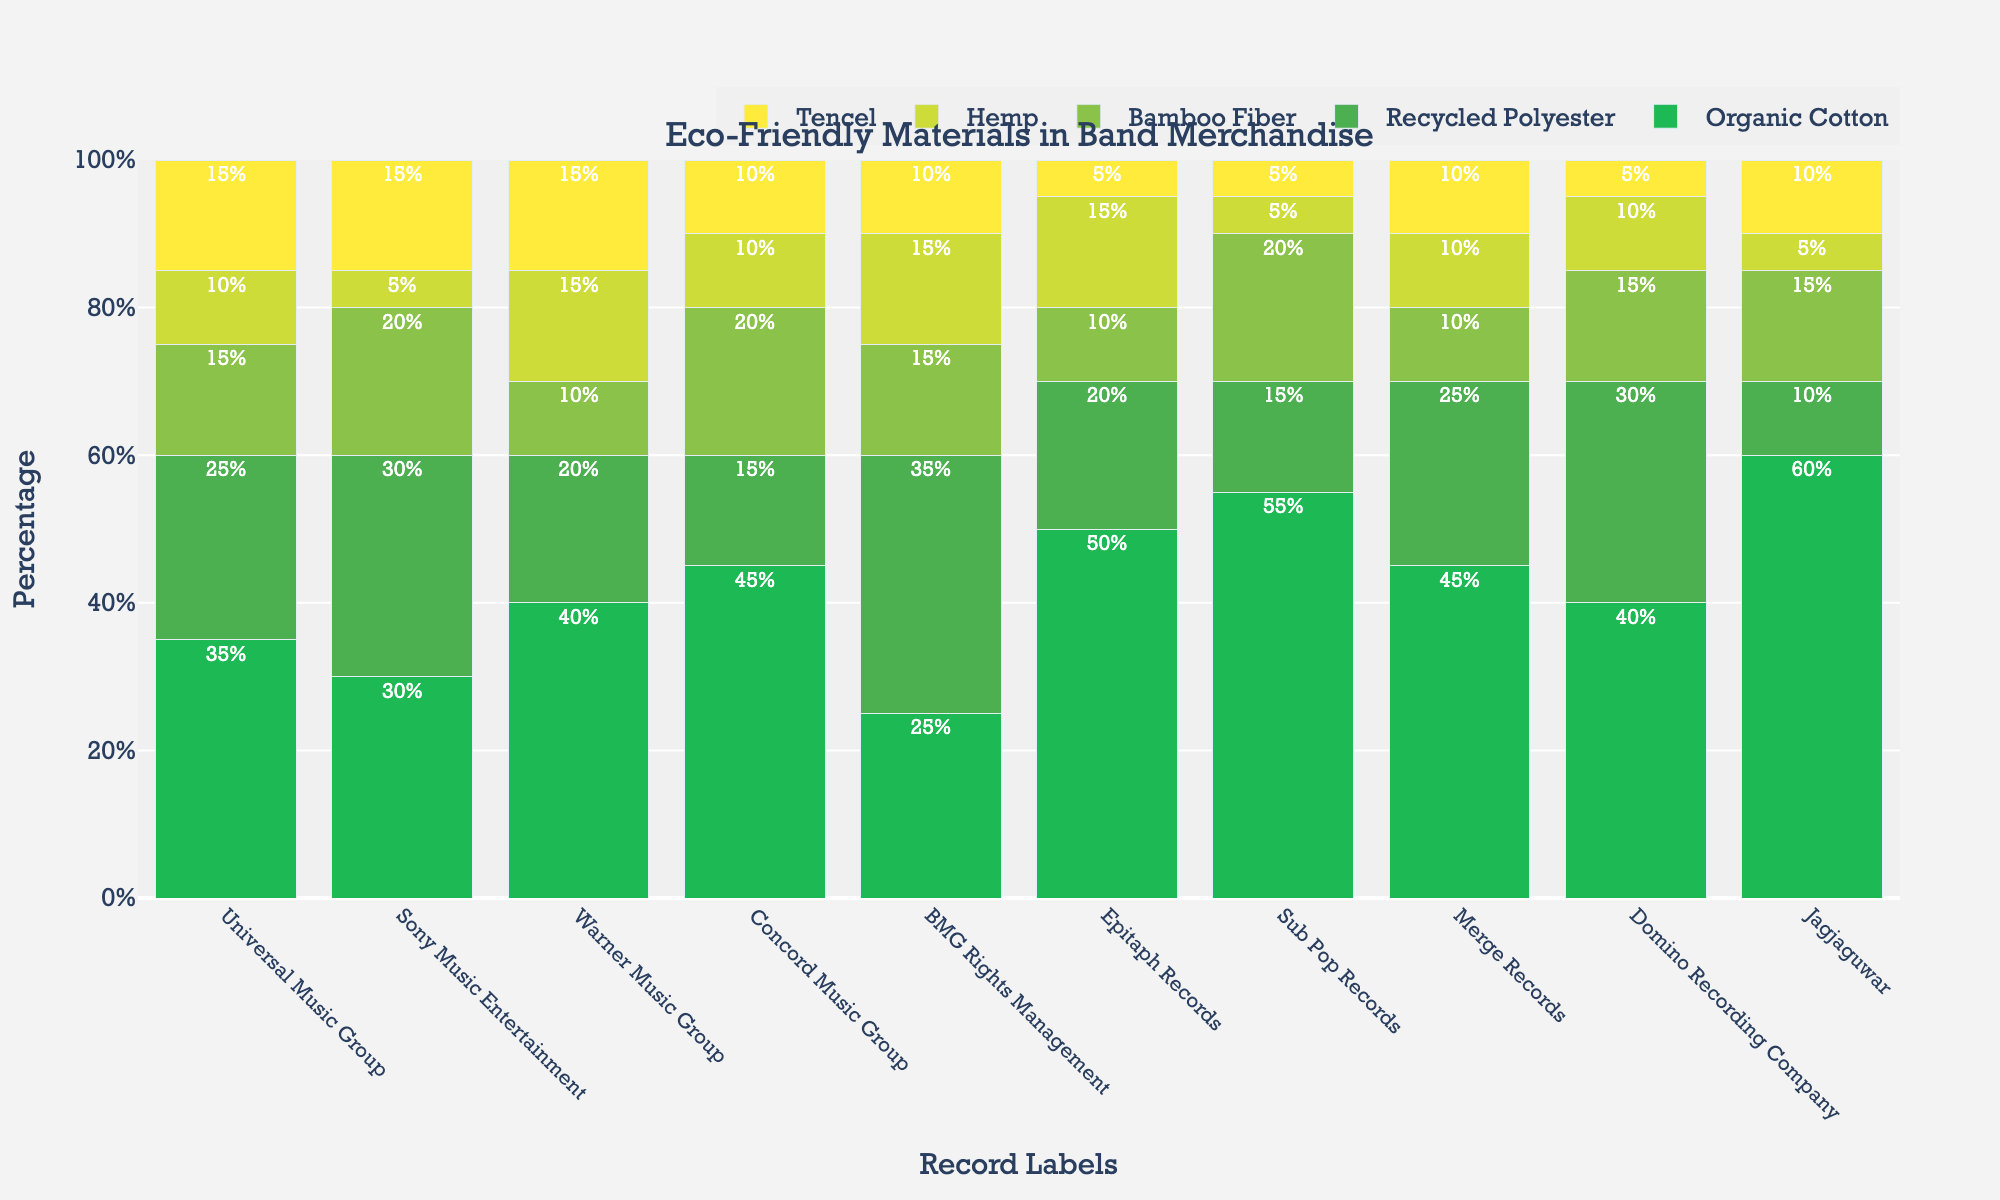What's the percentage of Organic Cotton used by Epitaph Records? Check the bar for Epitaph Records. The color representing Organic Cotton is the first one (green). The corresponding value is 50%.
Answer: 50% Which record label uses the most Bamboo Fiber? Compare the heights of the bars representing Bamboo Fiber across all labels. The highest bar of Bamboo Fiber (third color) is for Sony Music Entertainment and Sub Pop Records, both at 20%.
Answer: Sony Music Entertainment and Sub Pop Records Which record label uses the least amount of Tencel? Compare the lengths of the bars representing Tencel across all labels. There are multiple labels using the lowest amount of Tencel at 5% (Epitaph Records, Sub Pop Records and Domino Recording Company)
Answer: Epitaph Records, Sub Pop Records, and Domino Recording Company What’s the total percentage of Organic Cotton used by Universal Music Group and Warner Music Group combined? Add the percentage of Organic Cotton for Universal Music Group (35%) and Warner Music Group (40%). 35% + 40% = 75%
Answer: 75% Which material is used most consistently by all labels? Check the range of amounts used for each material across all labels. Tencel is used in a narrow range (5% to 15%) compared to others.
Answer: Tencel Which record label uses the highest percentage of eco-friendly materials? Sum the percentages for each material for each label. For example, Jagjaguwar has 60 (Organic Cotton) + 10 (Recycled Polyester) + 15 (Bamboo Fiber) + 5 (Hemp) + 10 (Tencel) = 100%. Jagjaguwar is one such label using full 100%.
Answer: Jagjaguwar How does the usage of Recycled Polyester compare between Universal Music Group and BMG Rights Management? Check the length of the bar for the second material (Recycled Polyester) for both labels. Universal Music Group uses 25%, whereas BMG Rights Management uses 35%.
Answer: BMG Rights Management uses more (35% vs. 25%) What is the average percentage of Hemp usage across all labels? Sum up the percentages of Hemp for each label and divide by the number of labels. (10 + 5 + 15 + 10 + 15 + 15 + 5 + 10 + 10 + 5) / 10 = 10%.
Answer: 10% Which record label has the highest percentage of Organic Cotton compared to other record labels? Check the bar heights for Organic Cotton across all labels. Jagjaguwar has the highest bar at 60%.
Answer: Jagjaguwar Which materials are used equally by Concord Music Group? Identify the bars with the same height for Concord Music Group. Bamboo Fiber and Recycled Polyester both are 20%.
Answer: Bamboo Fiber and Recycled Polyester How does the usage of Bamboo Fiber in Merge Records and Warner Music Group differ? Compare the bars of Bamboo Fiber (third material) for Merge Records (10%) and Warner Music Group (10%). Both have the same usage of 10%.
Answer: They are the same 